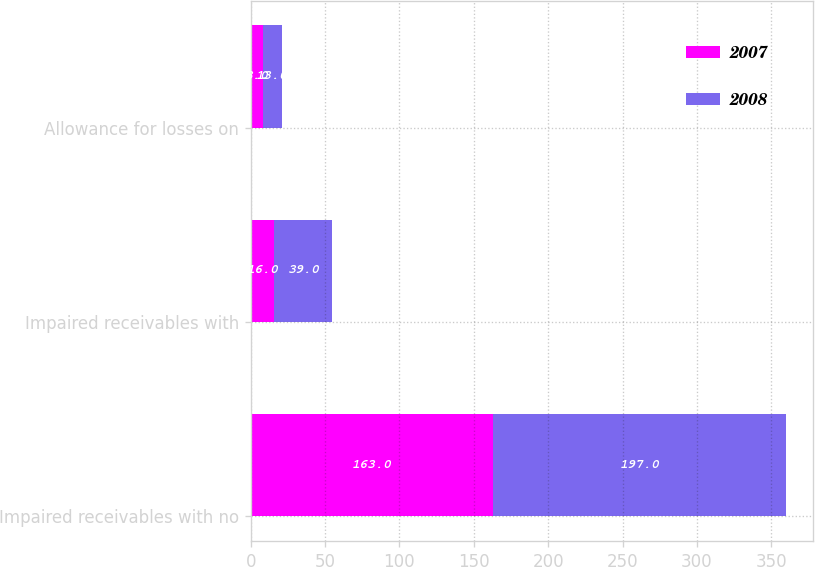Convert chart. <chart><loc_0><loc_0><loc_500><loc_500><stacked_bar_chart><ecel><fcel>Impaired receivables with no<fcel>Impaired receivables with<fcel>Allowance for losses on<nl><fcel>2007<fcel>163<fcel>16<fcel>8<nl><fcel>2008<fcel>197<fcel>39<fcel>13<nl></chart> 